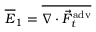Convert formula to latex. <formula><loc_0><loc_0><loc_500><loc_500>\overline { E } _ { 1 } = \overline { { \nabla \cdot \vec { F } _ { t } ^ { a d v } } }</formula> 